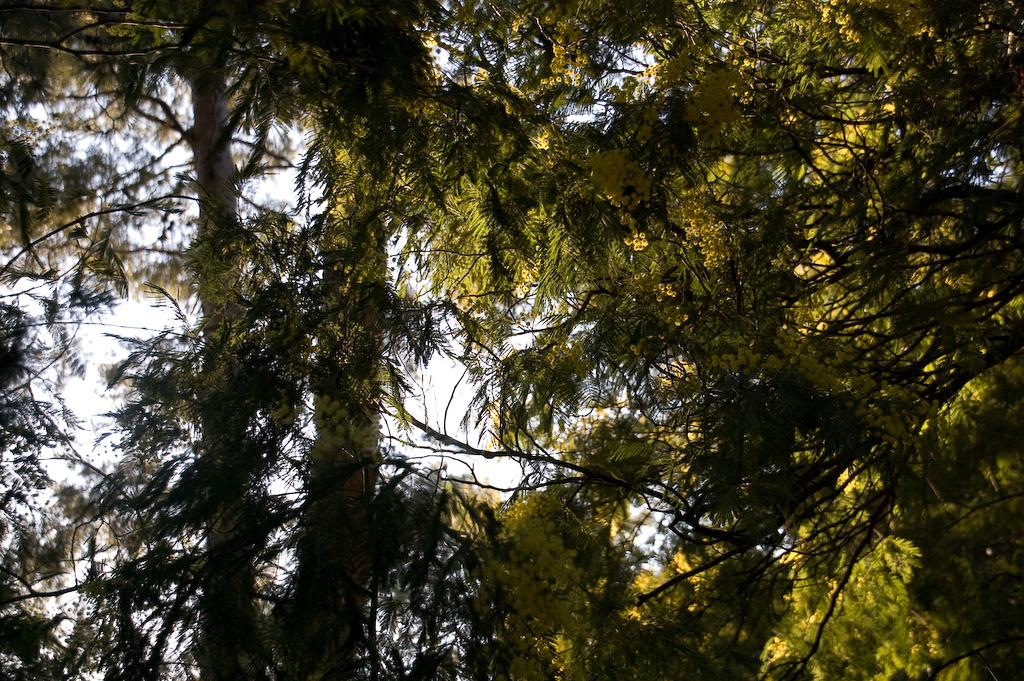What type of vegetation can be seen in the image? There are trees in the image. What is visible at the top of the image? The sky is visible at the top of the image. How does the plate move around in the image? There is no plate present in the image. What observation can be made about the trees in the image? The trees are stationary in the image and do not move or make any observations. 